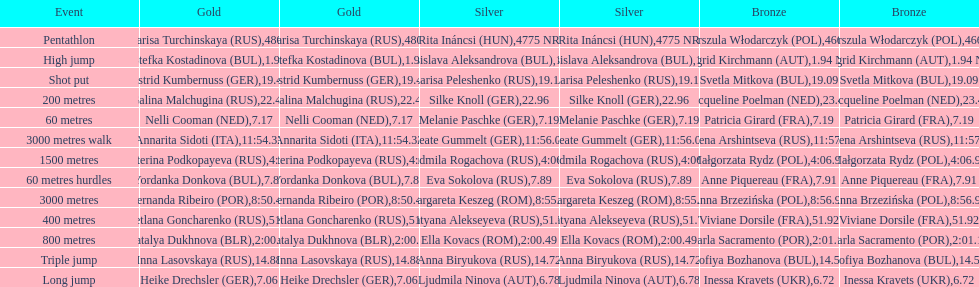How many german women won medals? 5. 